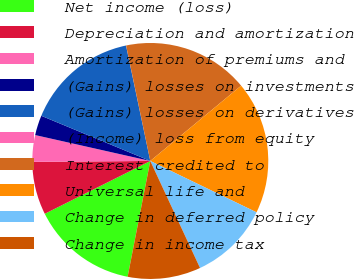<chart> <loc_0><loc_0><loc_500><loc_500><pie_chart><fcel>Net income (loss)<fcel>Depreciation and amortization<fcel>Amortization of premiums and<fcel>(Gains) losses on investments<fcel>(Gains) losses on derivatives<fcel>(Income) loss from equity<fcel>Interest credited to<fcel>Universal life and<fcel>Change in deferred policy<fcel>Change in income tax<nl><fcel>14.54%<fcel>7.27%<fcel>3.64%<fcel>2.73%<fcel>15.45%<fcel>0.01%<fcel>17.27%<fcel>18.18%<fcel>10.91%<fcel>10.0%<nl></chart> 